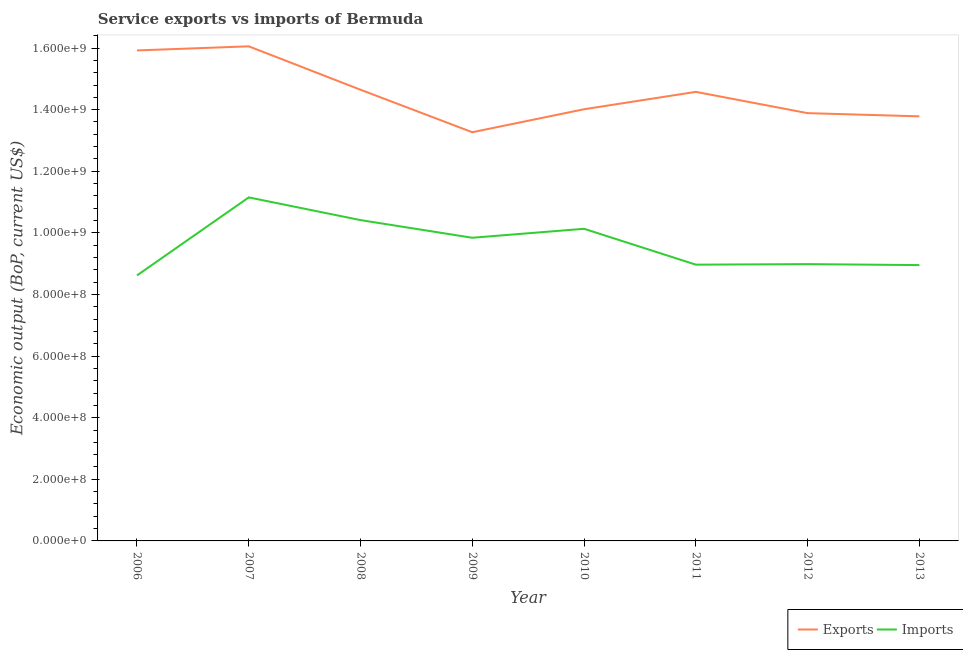Does the line corresponding to amount of service imports intersect with the line corresponding to amount of service exports?
Offer a terse response. No. What is the amount of service imports in 2008?
Ensure brevity in your answer.  1.04e+09. Across all years, what is the maximum amount of service exports?
Ensure brevity in your answer.  1.61e+09. Across all years, what is the minimum amount of service exports?
Ensure brevity in your answer.  1.33e+09. In which year was the amount of service exports maximum?
Provide a succinct answer. 2007. In which year was the amount of service exports minimum?
Offer a very short reply. 2009. What is the total amount of service imports in the graph?
Your answer should be compact. 7.71e+09. What is the difference between the amount of service exports in 2009 and that in 2013?
Provide a short and direct response. -5.16e+07. What is the difference between the amount of service imports in 2012 and the amount of service exports in 2010?
Offer a very short reply. -5.03e+08. What is the average amount of service imports per year?
Your answer should be very brief. 9.63e+08. In the year 2006, what is the difference between the amount of service exports and amount of service imports?
Make the answer very short. 7.30e+08. What is the ratio of the amount of service imports in 2008 to that in 2013?
Offer a terse response. 1.16. What is the difference between the highest and the second highest amount of service exports?
Give a very brief answer. 1.33e+07. What is the difference between the highest and the lowest amount of service imports?
Make the answer very short. 2.53e+08. In how many years, is the amount of service exports greater than the average amount of service exports taken over all years?
Provide a short and direct response. 4. Does the amount of service exports monotonically increase over the years?
Offer a terse response. No. Is the amount of service exports strictly less than the amount of service imports over the years?
Offer a terse response. No. How many lines are there?
Give a very brief answer. 2. How many years are there in the graph?
Keep it short and to the point. 8. Does the graph contain any zero values?
Provide a succinct answer. No. Does the graph contain grids?
Offer a terse response. No. Where does the legend appear in the graph?
Your answer should be compact. Bottom right. How are the legend labels stacked?
Your answer should be compact. Horizontal. What is the title of the graph?
Offer a terse response. Service exports vs imports of Bermuda. What is the label or title of the Y-axis?
Provide a short and direct response. Economic output (BoP, current US$). What is the Economic output (BoP, current US$) of Exports in 2006?
Keep it short and to the point. 1.59e+09. What is the Economic output (BoP, current US$) of Imports in 2006?
Make the answer very short. 8.62e+08. What is the Economic output (BoP, current US$) in Exports in 2007?
Provide a succinct answer. 1.61e+09. What is the Economic output (BoP, current US$) of Imports in 2007?
Give a very brief answer. 1.12e+09. What is the Economic output (BoP, current US$) in Exports in 2008?
Keep it short and to the point. 1.46e+09. What is the Economic output (BoP, current US$) of Imports in 2008?
Give a very brief answer. 1.04e+09. What is the Economic output (BoP, current US$) of Exports in 2009?
Offer a very short reply. 1.33e+09. What is the Economic output (BoP, current US$) of Imports in 2009?
Ensure brevity in your answer.  9.84e+08. What is the Economic output (BoP, current US$) of Exports in 2010?
Make the answer very short. 1.40e+09. What is the Economic output (BoP, current US$) in Imports in 2010?
Your answer should be compact. 1.01e+09. What is the Economic output (BoP, current US$) of Exports in 2011?
Offer a terse response. 1.46e+09. What is the Economic output (BoP, current US$) in Imports in 2011?
Your response must be concise. 8.97e+08. What is the Economic output (BoP, current US$) of Exports in 2012?
Provide a succinct answer. 1.39e+09. What is the Economic output (BoP, current US$) in Imports in 2012?
Your answer should be compact. 8.99e+08. What is the Economic output (BoP, current US$) in Exports in 2013?
Your answer should be compact. 1.38e+09. What is the Economic output (BoP, current US$) in Imports in 2013?
Provide a short and direct response. 8.95e+08. Across all years, what is the maximum Economic output (BoP, current US$) of Exports?
Keep it short and to the point. 1.61e+09. Across all years, what is the maximum Economic output (BoP, current US$) in Imports?
Your response must be concise. 1.12e+09. Across all years, what is the minimum Economic output (BoP, current US$) in Exports?
Offer a very short reply. 1.33e+09. Across all years, what is the minimum Economic output (BoP, current US$) in Imports?
Offer a very short reply. 8.62e+08. What is the total Economic output (BoP, current US$) in Exports in the graph?
Make the answer very short. 1.16e+1. What is the total Economic output (BoP, current US$) of Imports in the graph?
Provide a succinct answer. 7.71e+09. What is the difference between the Economic output (BoP, current US$) of Exports in 2006 and that in 2007?
Provide a short and direct response. -1.33e+07. What is the difference between the Economic output (BoP, current US$) of Imports in 2006 and that in 2007?
Your answer should be very brief. -2.53e+08. What is the difference between the Economic output (BoP, current US$) of Exports in 2006 and that in 2008?
Your answer should be compact. 1.28e+08. What is the difference between the Economic output (BoP, current US$) in Imports in 2006 and that in 2008?
Your response must be concise. -1.80e+08. What is the difference between the Economic output (BoP, current US$) of Exports in 2006 and that in 2009?
Your answer should be very brief. 2.66e+08. What is the difference between the Economic output (BoP, current US$) of Imports in 2006 and that in 2009?
Make the answer very short. -1.22e+08. What is the difference between the Economic output (BoP, current US$) in Exports in 2006 and that in 2010?
Keep it short and to the point. 1.91e+08. What is the difference between the Economic output (BoP, current US$) of Imports in 2006 and that in 2010?
Offer a very short reply. -1.51e+08. What is the difference between the Economic output (BoP, current US$) of Exports in 2006 and that in 2011?
Offer a terse response. 1.34e+08. What is the difference between the Economic output (BoP, current US$) in Imports in 2006 and that in 2011?
Ensure brevity in your answer.  -3.49e+07. What is the difference between the Economic output (BoP, current US$) of Exports in 2006 and that in 2012?
Keep it short and to the point. 2.04e+08. What is the difference between the Economic output (BoP, current US$) in Imports in 2006 and that in 2012?
Your response must be concise. -3.67e+07. What is the difference between the Economic output (BoP, current US$) in Exports in 2006 and that in 2013?
Your response must be concise. 2.14e+08. What is the difference between the Economic output (BoP, current US$) of Imports in 2006 and that in 2013?
Offer a terse response. -3.35e+07. What is the difference between the Economic output (BoP, current US$) of Exports in 2007 and that in 2008?
Offer a very short reply. 1.41e+08. What is the difference between the Economic output (BoP, current US$) in Imports in 2007 and that in 2008?
Keep it short and to the point. 7.37e+07. What is the difference between the Economic output (BoP, current US$) of Exports in 2007 and that in 2009?
Keep it short and to the point. 2.79e+08. What is the difference between the Economic output (BoP, current US$) of Imports in 2007 and that in 2009?
Your response must be concise. 1.31e+08. What is the difference between the Economic output (BoP, current US$) in Exports in 2007 and that in 2010?
Keep it short and to the point. 2.04e+08. What is the difference between the Economic output (BoP, current US$) in Imports in 2007 and that in 2010?
Give a very brief answer. 1.02e+08. What is the difference between the Economic output (BoP, current US$) of Exports in 2007 and that in 2011?
Provide a succinct answer. 1.48e+08. What is the difference between the Economic output (BoP, current US$) in Imports in 2007 and that in 2011?
Keep it short and to the point. 2.18e+08. What is the difference between the Economic output (BoP, current US$) of Exports in 2007 and that in 2012?
Provide a short and direct response. 2.17e+08. What is the difference between the Economic output (BoP, current US$) of Imports in 2007 and that in 2012?
Make the answer very short. 2.17e+08. What is the difference between the Economic output (BoP, current US$) of Exports in 2007 and that in 2013?
Keep it short and to the point. 2.27e+08. What is the difference between the Economic output (BoP, current US$) of Imports in 2007 and that in 2013?
Ensure brevity in your answer.  2.20e+08. What is the difference between the Economic output (BoP, current US$) of Exports in 2008 and that in 2009?
Offer a terse response. 1.38e+08. What is the difference between the Economic output (BoP, current US$) of Imports in 2008 and that in 2009?
Offer a terse response. 5.73e+07. What is the difference between the Economic output (BoP, current US$) of Exports in 2008 and that in 2010?
Give a very brief answer. 6.33e+07. What is the difference between the Economic output (BoP, current US$) of Imports in 2008 and that in 2010?
Give a very brief answer. 2.82e+07. What is the difference between the Economic output (BoP, current US$) in Exports in 2008 and that in 2011?
Your response must be concise. 6.87e+06. What is the difference between the Economic output (BoP, current US$) of Imports in 2008 and that in 2011?
Your answer should be very brief. 1.45e+08. What is the difference between the Economic output (BoP, current US$) of Exports in 2008 and that in 2012?
Your answer should be compact. 7.59e+07. What is the difference between the Economic output (BoP, current US$) in Imports in 2008 and that in 2012?
Provide a succinct answer. 1.43e+08. What is the difference between the Economic output (BoP, current US$) in Exports in 2008 and that in 2013?
Offer a very short reply. 8.63e+07. What is the difference between the Economic output (BoP, current US$) in Imports in 2008 and that in 2013?
Your response must be concise. 1.46e+08. What is the difference between the Economic output (BoP, current US$) of Exports in 2009 and that in 2010?
Provide a succinct answer. -7.46e+07. What is the difference between the Economic output (BoP, current US$) in Imports in 2009 and that in 2010?
Offer a very short reply. -2.91e+07. What is the difference between the Economic output (BoP, current US$) in Exports in 2009 and that in 2011?
Your answer should be very brief. -1.31e+08. What is the difference between the Economic output (BoP, current US$) of Imports in 2009 and that in 2011?
Your answer should be compact. 8.73e+07. What is the difference between the Economic output (BoP, current US$) of Exports in 2009 and that in 2012?
Your answer should be compact. -6.20e+07. What is the difference between the Economic output (BoP, current US$) in Imports in 2009 and that in 2012?
Keep it short and to the point. 8.56e+07. What is the difference between the Economic output (BoP, current US$) in Exports in 2009 and that in 2013?
Your answer should be very brief. -5.16e+07. What is the difference between the Economic output (BoP, current US$) of Imports in 2009 and that in 2013?
Your response must be concise. 8.87e+07. What is the difference between the Economic output (BoP, current US$) of Exports in 2010 and that in 2011?
Your answer should be very brief. -5.64e+07. What is the difference between the Economic output (BoP, current US$) of Imports in 2010 and that in 2011?
Your answer should be very brief. 1.16e+08. What is the difference between the Economic output (BoP, current US$) in Exports in 2010 and that in 2012?
Provide a succinct answer. 1.26e+07. What is the difference between the Economic output (BoP, current US$) in Imports in 2010 and that in 2012?
Your answer should be compact. 1.15e+08. What is the difference between the Economic output (BoP, current US$) in Exports in 2010 and that in 2013?
Provide a succinct answer. 2.30e+07. What is the difference between the Economic output (BoP, current US$) of Imports in 2010 and that in 2013?
Your response must be concise. 1.18e+08. What is the difference between the Economic output (BoP, current US$) in Exports in 2011 and that in 2012?
Make the answer very short. 6.91e+07. What is the difference between the Economic output (BoP, current US$) of Imports in 2011 and that in 2012?
Provide a short and direct response. -1.77e+06. What is the difference between the Economic output (BoP, current US$) in Exports in 2011 and that in 2013?
Keep it short and to the point. 7.95e+07. What is the difference between the Economic output (BoP, current US$) of Imports in 2011 and that in 2013?
Offer a very short reply. 1.39e+06. What is the difference between the Economic output (BoP, current US$) of Exports in 2012 and that in 2013?
Offer a very short reply. 1.04e+07. What is the difference between the Economic output (BoP, current US$) of Imports in 2012 and that in 2013?
Your answer should be compact. 3.16e+06. What is the difference between the Economic output (BoP, current US$) of Exports in 2006 and the Economic output (BoP, current US$) of Imports in 2007?
Give a very brief answer. 4.77e+08. What is the difference between the Economic output (BoP, current US$) in Exports in 2006 and the Economic output (BoP, current US$) in Imports in 2008?
Ensure brevity in your answer.  5.51e+08. What is the difference between the Economic output (BoP, current US$) of Exports in 2006 and the Economic output (BoP, current US$) of Imports in 2009?
Offer a very short reply. 6.08e+08. What is the difference between the Economic output (BoP, current US$) in Exports in 2006 and the Economic output (BoP, current US$) in Imports in 2010?
Ensure brevity in your answer.  5.79e+08. What is the difference between the Economic output (BoP, current US$) of Exports in 2006 and the Economic output (BoP, current US$) of Imports in 2011?
Your answer should be compact. 6.95e+08. What is the difference between the Economic output (BoP, current US$) in Exports in 2006 and the Economic output (BoP, current US$) in Imports in 2012?
Your answer should be very brief. 6.94e+08. What is the difference between the Economic output (BoP, current US$) of Exports in 2006 and the Economic output (BoP, current US$) of Imports in 2013?
Provide a succinct answer. 6.97e+08. What is the difference between the Economic output (BoP, current US$) in Exports in 2007 and the Economic output (BoP, current US$) in Imports in 2008?
Offer a terse response. 5.64e+08. What is the difference between the Economic output (BoP, current US$) in Exports in 2007 and the Economic output (BoP, current US$) in Imports in 2009?
Give a very brief answer. 6.21e+08. What is the difference between the Economic output (BoP, current US$) in Exports in 2007 and the Economic output (BoP, current US$) in Imports in 2010?
Offer a terse response. 5.92e+08. What is the difference between the Economic output (BoP, current US$) of Exports in 2007 and the Economic output (BoP, current US$) of Imports in 2011?
Provide a succinct answer. 7.09e+08. What is the difference between the Economic output (BoP, current US$) of Exports in 2007 and the Economic output (BoP, current US$) of Imports in 2012?
Offer a very short reply. 7.07e+08. What is the difference between the Economic output (BoP, current US$) in Exports in 2007 and the Economic output (BoP, current US$) in Imports in 2013?
Give a very brief answer. 7.10e+08. What is the difference between the Economic output (BoP, current US$) in Exports in 2008 and the Economic output (BoP, current US$) in Imports in 2009?
Give a very brief answer. 4.81e+08. What is the difference between the Economic output (BoP, current US$) of Exports in 2008 and the Economic output (BoP, current US$) of Imports in 2010?
Your answer should be compact. 4.51e+08. What is the difference between the Economic output (BoP, current US$) in Exports in 2008 and the Economic output (BoP, current US$) in Imports in 2011?
Provide a short and direct response. 5.68e+08. What is the difference between the Economic output (BoP, current US$) in Exports in 2008 and the Economic output (BoP, current US$) in Imports in 2012?
Offer a very short reply. 5.66e+08. What is the difference between the Economic output (BoP, current US$) of Exports in 2008 and the Economic output (BoP, current US$) of Imports in 2013?
Keep it short and to the point. 5.69e+08. What is the difference between the Economic output (BoP, current US$) of Exports in 2009 and the Economic output (BoP, current US$) of Imports in 2010?
Provide a succinct answer. 3.13e+08. What is the difference between the Economic output (BoP, current US$) of Exports in 2009 and the Economic output (BoP, current US$) of Imports in 2011?
Your answer should be very brief. 4.30e+08. What is the difference between the Economic output (BoP, current US$) in Exports in 2009 and the Economic output (BoP, current US$) in Imports in 2012?
Ensure brevity in your answer.  4.28e+08. What is the difference between the Economic output (BoP, current US$) in Exports in 2009 and the Economic output (BoP, current US$) in Imports in 2013?
Give a very brief answer. 4.31e+08. What is the difference between the Economic output (BoP, current US$) of Exports in 2010 and the Economic output (BoP, current US$) of Imports in 2011?
Keep it short and to the point. 5.05e+08. What is the difference between the Economic output (BoP, current US$) in Exports in 2010 and the Economic output (BoP, current US$) in Imports in 2012?
Offer a very short reply. 5.03e+08. What is the difference between the Economic output (BoP, current US$) in Exports in 2010 and the Economic output (BoP, current US$) in Imports in 2013?
Your answer should be very brief. 5.06e+08. What is the difference between the Economic output (BoP, current US$) in Exports in 2011 and the Economic output (BoP, current US$) in Imports in 2012?
Keep it short and to the point. 5.59e+08. What is the difference between the Economic output (BoP, current US$) in Exports in 2011 and the Economic output (BoP, current US$) in Imports in 2013?
Provide a succinct answer. 5.62e+08. What is the difference between the Economic output (BoP, current US$) of Exports in 2012 and the Economic output (BoP, current US$) of Imports in 2013?
Your answer should be very brief. 4.93e+08. What is the average Economic output (BoP, current US$) of Exports per year?
Offer a terse response. 1.45e+09. What is the average Economic output (BoP, current US$) in Imports per year?
Your answer should be compact. 9.63e+08. In the year 2006, what is the difference between the Economic output (BoP, current US$) of Exports and Economic output (BoP, current US$) of Imports?
Offer a very short reply. 7.30e+08. In the year 2007, what is the difference between the Economic output (BoP, current US$) in Exports and Economic output (BoP, current US$) in Imports?
Your answer should be compact. 4.90e+08. In the year 2008, what is the difference between the Economic output (BoP, current US$) of Exports and Economic output (BoP, current US$) of Imports?
Offer a very short reply. 4.23e+08. In the year 2009, what is the difference between the Economic output (BoP, current US$) of Exports and Economic output (BoP, current US$) of Imports?
Your response must be concise. 3.43e+08. In the year 2010, what is the difference between the Economic output (BoP, current US$) in Exports and Economic output (BoP, current US$) in Imports?
Your response must be concise. 3.88e+08. In the year 2011, what is the difference between the Economic output (BoP, current US$) of Exports and Economic output (BoP, current US$) of Imports?
Make the answer very short. 5.61e+08. In the year 2012, what is the difference between the Economic output (BoP, current US$) in Exports and Economic output (BoP, current US$) in Imports?
Provide a succinct answer. 4.90e+08. In the year 2013, what is the difference between the Economic output (BoP, current US$) in Exports and Economic output (BoP, current US$) in Imports?
Provide a succinct answer. 4.83e+08. What is the ratio of the Economic output (BoP, current US$) in Imports in 2006 to that in 2007?
Offer a terse response. 0.77. What is the ratio of the Economic output (BoP, current US$) in Exports in 2006 to that in 2008?
Offer a terse response. 1.09. What is the ratio of the Economic output (BoP, current US$) in Imports in 2006 to that in 2008?
Offer a very short reply. 0.83. What is the ratio of the Economic output (BoP, current US$) in Exports in 2006 to that in 2009?
Keep it short and to the point. 1.2. What is the ratio of the Economic output (BoP, current US$) of Imports in 2006 to that in 2009?
Ensure brevity in your answer.  0.88. What is the ratio of the Economic output (BoP, current US$) in Exports in 2006 to that in 2010?
Provide a short and direct response. 1.14. What is the ratio of the Economic output (BoP, current US$) of Imports in 2006 to that in 2010?
Your answer should be very brief. 0.85. What is the ratio of the Economic output (BoP, current US$) in Exports in 2006 to that in 2011?
Make the answer very short. 1.09. What is the ratio of the Economic output (BoP, current US$) of Imports in 2006 to that in 2011?
Your response must be concise. 0.96. What is the ratio of the Economic output (BoP, current US$) of Exports in 2006 to that in 2012?
Your answer should be compact. 1.15. What is the ratio of the Economic output (BoP, current US$) of Imports in 2006 to that in 2012?
Your answer should be compact. 0.96. What is the ratio of the Economic output (BoP, current US$) in Exports in 2006 to that in 2013?
Offer a very short reply. 1.16. What is the ratio of the Economic output (BoP, current US$) of Imports in 2006 to that in 2013?
Your answer should be compact. 0.96. What is the ratio of the Economic output (BoP, current US$) in Exports in 2007 to that in 2008?
Your response must be concise. 1.1. What is the ratio of the Economic output (BoP, current US$) of Imports in 2007 to that in 2008?
Provide a succinct answer. 1.07. What is the ratio of the Economic output (BoP, current US$) in Exports in 2007 to that in 2009?
Offer a terse response. 1.21. What is the ratio of the Economic output (BoP, current US$) in Imports in 2007 to that in 2009?
Keep it short and to the point. 1.13. What is the ratio of the Economic output (BoP, current US$) of Exports in 2007 to that in 2010?
Your answer should be compact. 1.15. What is the ratio of the Economic output (BoP, current US$) in Imports in 2007 to that in 2010?
Offer a terse response. 1.1. What is the ratio of the Economic output (BoP, current US$) in Exports in 2007 to that in 2011?
Provide a succinct answer. 1.1. What is the ratio of the Economic output (BoP, current US$) of Imports in 2007 to that in 2011?
Offer a very short reply. 1.24. What is the ratio of the Economic output (BoP, current US$) of Exports in 2007 to that in 2012?
Provide a succinct answer. 1.16. What is the ratio of the Economic output (BoP, current US$) of Imports in 2007 to that in 2012?
Give a very brief answer. 1.24. What is the ratio of the Economic output (BoP, current US$) in Exports in 2007 to that in 2013?
Offer a terse response. 1.16. What is the ratio of the Economic output (BoP, current US$) in Imports in 2007 to that in 2013?
Provide a succinct answer. 1.25. What is the ratio of the Economic output (BoP, current US$) in Exports in 2008 to that in 2009?
Give a very brief answer. 1.1. What is the ratio of the Economic output (BoP, current US$) of Imports in 2008 to that in 2009?
Your answer should be compact. 1.06. What is the ratio of the Economic output (BoP, current US$) in Exports in 2008 to that in 2010?
Your answer should be compact. 1.05. What is the ratio of the Economic output (BoP, current US$) in Imports in 2008 to that in 2010?
Offer a terse response. 1.03. What is the ratio of the Economic output (BoP, current US$) in Imports in 2008 to that in 2011?
Make the answer very short. 1.16. What is the ratio of the Economic output (BoP, current US$) of Exports in 2008 to that in 2012?
Your answer should be very brief. 1.05. What is the ratio of the Economic output (BoP, current US$) of Imports in 2008 to that in 2012?
Provide a short and direct response. 1.16. What is the ratio of the Economic output (BoP, current US$) in Exports in 2008 to that in 2013?
Offer a terse response. 1.06. What is the ratio of the Economic output (BoP, current US$) of Imports in 2008 to that in 2013?
Provide a succinct answer. 1.16. What is the ratio of the Economic output (BoP, current US$) of Exports in 2009 to that in 2010?
Your answer should be very brief. 0.95. What is the ratio of the Economic output (BoP, current US$) in Imports in 2009 to that in 2010?
Ensure brevity in your answer.  0.97. What is the ratio of the Economic output (BoP, current US$) in Exports in 2009 to that in 2011?
Offer a terse response. 0.91. What is the ratio of the Economic output (BoP, current US$) of Imports in 2009 to that in 2011?
Your response must be concise. 1.1. What is the ratio of the Economic output (BoP, current US$) of Exports in 2009 to that in 2012?
Your answer should be very brief. 0.96. What is the ratio of the Economic output (BoP, current US$) of Imports in 2009 to that in 2012?
Your answer should be very brief. 1.1. What is the ratio of the Economic output (BoP, current US$) in Exports in 2009 to that in 2013?
Your answer should be very brief. 0.96. What is the ratio of the Economic output (BoP, current US$) in Imports in 2009 to that in 2013?
Give a very brief answer. 1.1. What is the ratio of the Economic output (BoP, current US$) of Exports in 2010 to that in 2011?
Give a very brief answer. 0.96. What is the ratio of the Economic output (BoP, current US$) in Imports in 2010 to that in 2011?
Offer a terse response. 1.13. What is the ratio of the Economic output (BoP, current US$) of Exports in 2010 to that in 2012?
Offer a terse response. 1.01. What is the ratio of the Economic output (BoP, current US$) in Imports in 2010 to that in 2012?
Provide a short and direct response. 1.13. What is the ratio of the Economic output (BoP, current US$) of Exports in 2010 to that in 2013?
Offer a terse response. 1.02. What is the ratio of the Economic output (BoP, current US$) of Imports in 2010 to that in 2013?
Your answer should be very brief. 1.13. What is the ratio of the Economic output (BoP, current US$) of Exports in 2011 to that in 2012?
Provide a short and direct response. 1.05. What is the ratio of the Economic output (BoP, current US$) of Imports in 2011 to that in 2012?
Provide a short and direct response. 1. What is the ratio of the Economic output (BoP, current US$) in Exports in 2011 to that in 2013?
Your answer should be very brief. 1.06. What is the ratio of the Economic output (BoP, current US$) of Exports in 2012 to that in 2013?
Your answer should be compact. 1.01. What is the difference between the highest and the second highest Economic output (BoP, current US$) of Exports?
Provide a short and direct response. 1.33e+07. What is the difference between the highest and the second highest Economic output (BoP, current US$) of Imports?
Your answer should be very brief. 7.37e+07. What is the difference between the highest and the lowest Economic output (BoP, current US$) of Exports?
Offer a very short reply. 2.79e+08. What is the difference between the highest and the lowest Economic output (BoP, current US$) in Imports?
Make the answer very short. 2.53e+08. 